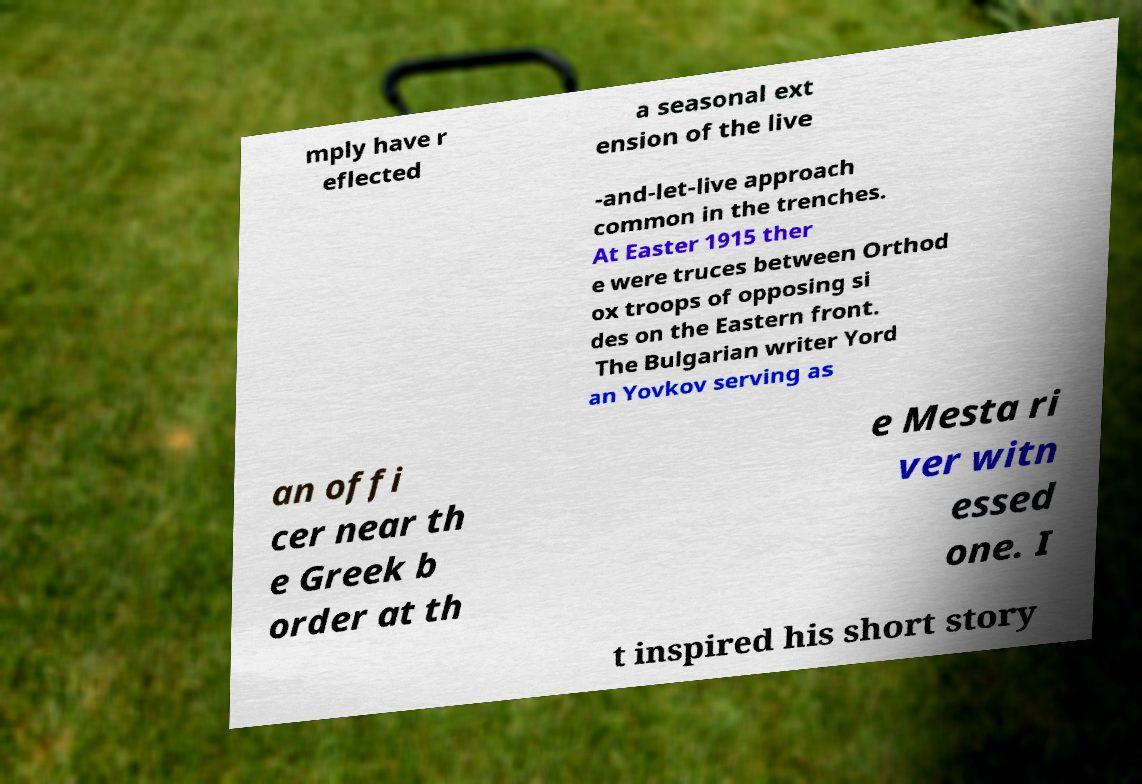Could you assist in decoding the text presented in this image and type it out clearly? mply have r eflected a seasonal ext ension of the live -and-let-live approach common in the trenches. At Easter 1915 ther e were truces between Orthod ox troops of opposing si des on the Eastern front. The Bulgarian writer Yord an Yovkov serving as an offi cer near th e Greek b order at th e Mesta ri ver witn essed one. I t inspired his short story 